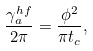Convert formula to latex. <formula><loc_0><loc_0><loc_500><loc_500>\frac { \gamma ^ { h f } _ { a } } { 2 \pi } = \frac { \phi ^ { 2 } } { \pi t _ { c } } ,</formula> 